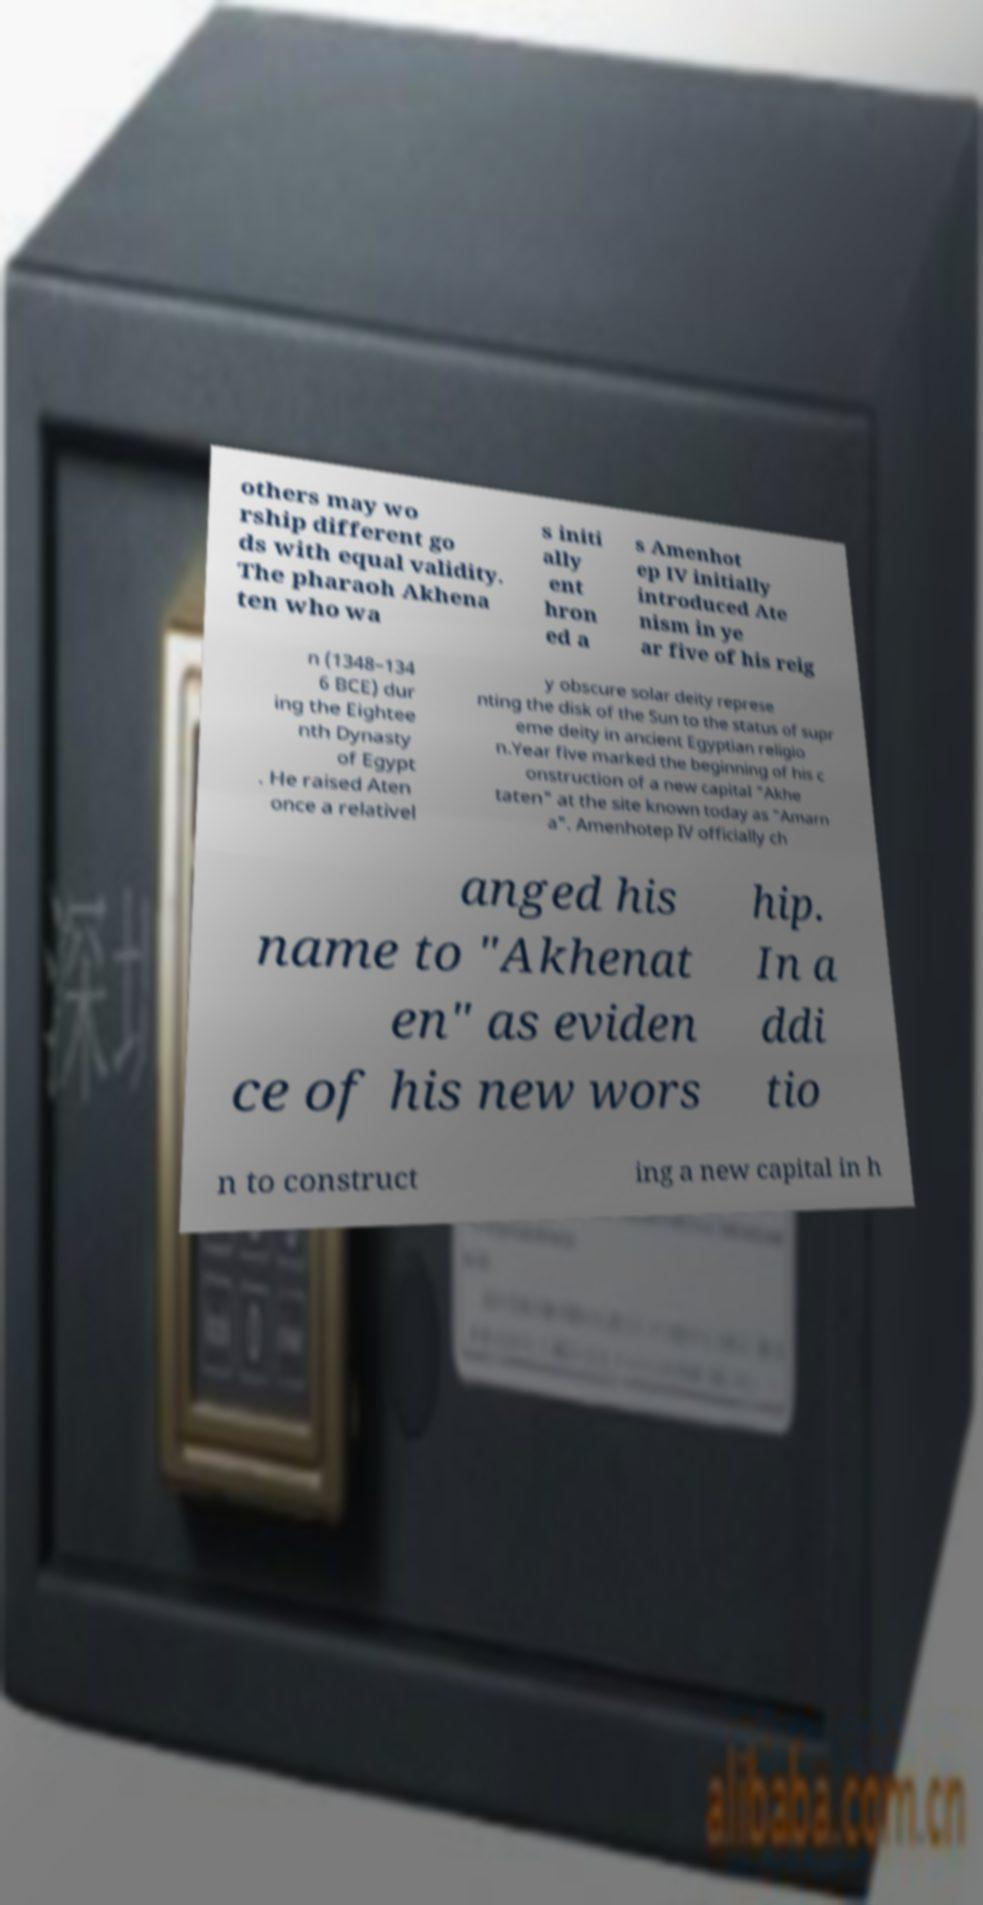Could you assist in decoding the text presented in this image and type it out clearly? others may wo rship different go ds with equal validity. The pharaoh Akhena ten who wa s initi ally ent hron ed a s Amenhot ep IV initially introduced Ate nism in ye ar five of his reig n (1348–134 6 BCE) dur ing the Eightee nth Dynasty of Egypt . He raised Aten once a relativel y obscure solar deity represe nting the disk of the Sun to the status of supr eme deity in ancient Egyptian religio n.Year five marked the beginning of his c onstruction of a new capital "Akhe taten" at the site known today as "Amarn a". Amenhotep IV officially ch anged his name to "Akhenat en" as eviden ce of his new wors hip. In a ddi tio n to construct ing a new capital in h 